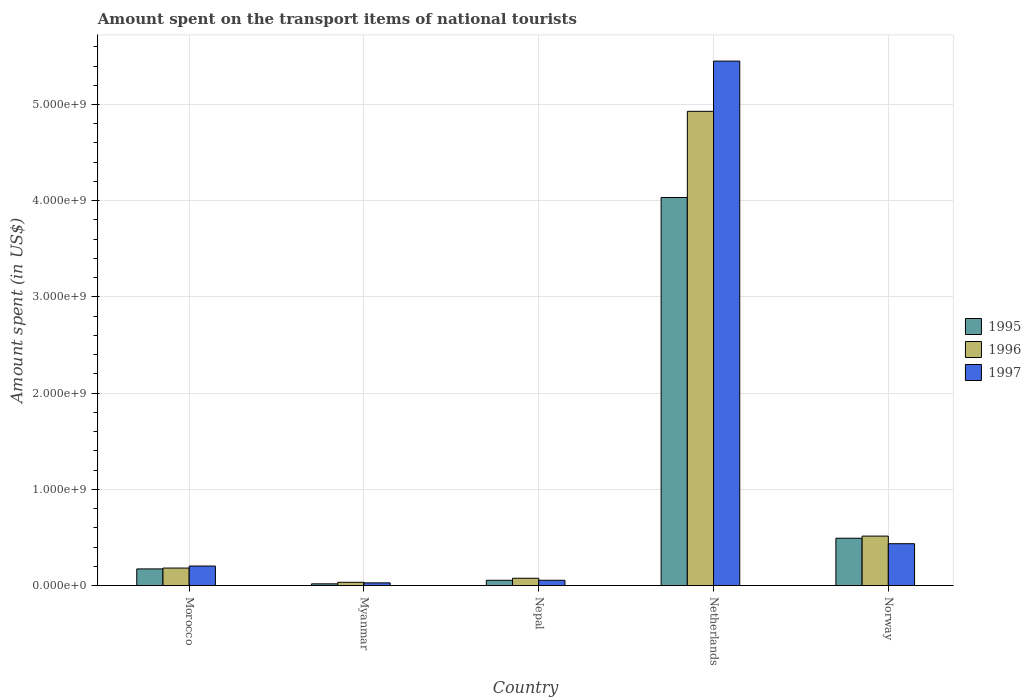How many different coloured bars are there?
Offer a very short reply. 3. Are the number of bars per tick equal to the number of legend labels?
Give a very brief answer. Yes. How many bars are there on the 5th tick from the left?
Offer a very short reply. 3. What is the label of the 2nd group of bars from the left?
Provide a short and direct response. Myanmar. In how many cases, is the number of bars for a given country not equal to the number of legend labels?
Provide a short and direct response. 0. What is the amount spent on the transport items of national tourists in 1997 in Nepal?
Ensure brevity in your answer.  5.50e+07. Across all countries, what is the maximum amount spent on the transport items of national tourists in 1997?
Offer a very short reply. 5.45e+09. Across all countries, what is the minimum amount spent on the transport items of national tourists in 1997?
Your answer should be very brief. 2.80e+07. In which country was the amount spent on the transport items of national tourists in 1997 minimum?
Ensure brevity in your answer.  Myanmar. What is the total amount spent on the transport items of national tourists in 1995 in the graph?
Your response must be concise. 4.77e+09. What is the difference between the amount spent on the transport items of national tourists in 1996 in Morocco and that in Netherlands?
Ensure brevity in your answer.  -4.75e+09. What is the difference between the amount spent on the transport items of national tourists in 1996 in Netherlands and the amount spent on the transport items of national tourists in 1997 in Nepal?
Ensure brevity in your answer.  4.87e+09. What is the average amount spent on the transport items of national tourists in 1996 per country?
Your answer should be compact. 1.15e+09. What is the difference between the amount spent on the transport items of national tourists of/in 1997 and amount spent on the transport items of national tourists of/in 1996 in Netherlands?
Your response must be concise. 5.22e+08. What is the ratio of the amount spent on the transport items of national tourists in 1996 in Morocco to that in Myanmar?
Keep it short and to the point. 5.35. What is the difference between the highest and the second highest amount spent on the transport items of national tourists in 1997?
Offer a very short reply. 5.25e+09. What is the difference between the highest and the lowest amount spent on the transport items of national tourists in 1996?
Provide a short and direct response. 4.90e+09. In how many countries, is the amount spent on the transport items of national tourists in 1997 greater than the average amount spent on the transport items of national tourists in 1997 taken over all countries?
Provide a short and direct response. 1. Is the sum of the amount spent on the transport items of national tourists in 1996 in Myanmar and Netherlands greater than the maximum amount spent on the transport items of national tourists in 1997 across all countries?
Your answer should be compact. No. What does the 2nd bar from the right in Morocco represents?
Provide a short and direct response. 1996. Is it the case that in every country, the sum of the amount spent on the transport items of national tourists in 1997 and amount spent on the transport items of national tourists in 1995 is greater than the amount spent on the transport items of national tourists in 1996?
Make the answer very short. Yes. How many bars are there?
Keep it short and to the point. 15. Are the values on the major ticks of Y-axis written in scientific E-notation?
Provide a succinct answer. Yes. How many legend labels are there?
Provide a short and direct response. 3. What is the title of the graph?
Provide a succinct answer. Amount spent on the transport items of national tourists. Does "2003" appear as one of the legend labels in the graph?
Your answer should be very brief. No. What is the label or title of the X-axis?
Your answer should be very brief. Country. What is the label or title of the Y-axis?
Ensure brevity in your answer.  Amount spent (in US$). What is the Amount spent (in US$) in 1995 in Morocco?
Offer a very short reply. 1.73e+08. What is the Amount spent (in US$) in 1996 in Morocco?
Your response must be concise. 1.82e+08. What is the Amount spent (in US$) of 1997 in Morocco?
Give a very brief answer. 2.03e+08. What is the Amount spent (in US$) in 1995 in Myanmar?
Offer a very short reply. 1.80e+07. What is the Amount spent (in US$) in 1996 in Myanmar?
Keep it short and to the point. 3.40e+07. What is the Amount spent (in US$) of 1997 in Myanmar?
Give a very brief answer. 2.80e+07. What is the Amount spent (in US$) in 1995 in Nepal?
Ensure brevity in your answer.  5.50e+07. What is the Amount spent (in US$) in 1996 in Nepal?
Ensure brevity in your answer.  7.60e+07. What is the Amount spent (in US$) in 1997 in Nepal?
Your answer should be compact. 5.50e+07. What is the Amount spent (in US$) in 1995 in Netherlands?
Provide a succinct answer. 4.03e+09. What is the Amount spent (in US$) in 1996 in Netherlands?
Provide a short and direct response. 4.93e+09. What is the Amount spent (in US$) of 1997 in Netherlands?
Provide a succinct answer. 5.45e+09. What is the Amount spent (in US$) in 1995 in Norway?
Give a very brief answer. 4.92e+08. What is the Amount spent (in US$) of 1996 in Norway?
Offer a very short reply. 5.14e+08. What is the Amount spent (in US$) in 1997 in Norway?
Ensure brevity in your answer.  4.35e+08. Across all countries, what is the maximum Amount spent (in US$) of 1995?
Your answer should be compact. 4.03e+09. Across all countries, what is the maximum Amount spent (in US$) of 1996?
Make the answer very short. 4.93e+09. Across all countries, what is the maximum Amount spent (in US$) of 1997?
Your answer should be very brief. 5.45e+09. Across all countries, what is the minimum Amount spent (in US$) in 1995?
Provide a succinct answer. 1.80e+07. Across all countries, what is the minimum Amount spent (in US$) in 1996?
Offer a very short reply. 3.40e+07. Across all countries, what is the minimum Amount spent (in US$) in 1997?
Keep it short and to the point. 2.80e+07. What is the total Amount spent (in US$) in 1995 in the graph?
Provide a short and direct response. 4.77e+09. What is the total Amount spent (in US$) in 1996 in the graph?
Offer a very short reply. 5.74e+09. What is the total Amount spent (in US$) of 1997 in the graph?
Make the answer very short. 6.17e+09. What is the difference between the Amount spent (in US$) in 1995 in Morocco and that in Myanmar?
Provide a short and direct response. 1.55e+08. What is the difference between the Amount spent (in US$) of 1996 in Morocco and that in Myanmar?
Give a very brief answer. 1.48e+08. What is the difference between the Amount spent (in US$) in 1997 in Morocco and that in Myanmar?
Give a very brief answer. 1.75e+08. What is the difference between the Amount spent (in US$) in 1995 in Morocco and that in Nepal?
Offer a terse response. 1.18e+08. What is the difference between the Amount spent (in US$) in 1996 in Morocco and that in Nepal?
Provide a succinct answer. 1.06e+08. What is the difference between the Amount spent (in US$) of 1997 in Morocco and that in Nepal?
Your answer should be compact. 1.48e+08. What is the difference between the Amount spent (in US$) of 1995 in Morocco and that in Netherlands?
Keep it short and to the point. -3.86e+09. What is the difference between the Amount spent (in US$) of 1996 in Morocco and that in Netherlands?
Make the answer very short. -4.75e+09. What is the difference between the Amount spent (in US$) of 1997 in Morocco and that in Netherlands?
Make the answer very short. -5.25e+09. What is the difference between the Amount spent (in US$) in 1995 in Morocco and that in Norway?
Keep it short and to the point. -3.19e+08. What is the difference between the Amount spent (in US$) in 1996 in Morocco and that in Norway?
Offer a very short reply. -3.32e+08. What is the difference between the Amount spent (in US$) of 1997 in Morocco and that in Norway?
Offer a very short reply. -2.32e+08. What is the difference between the Amount spent (in US$) in 1995 in Myanmar and that in Nepal?
Make the answer very short. -3.70e+07. What is the difference between the Amount spent (in US$) of 1996 in Myanmar and that in Nepal?
Provide a short and direct response. -4.20e+07. What is the difference between the Amount spent (in US$) of 1997 in Myanmar and that in Nepal?
Make the answer very short. -2.70e+07. What is the difference between the Amount spent (in US$) in 1995 in Myanmar and that in Netherlands?
Give a very brief answer. -4.02e+09. What is the difference between the Amount spent (in US$) in 1996 in Myanmar and that in Netherlands?
Make the answer very short. -4.90e+09. What is the difference between the Amount spent (in US$) in 1997 in Myanmar and that in Netherlands?
Your response must be concise. -5.42e+09. What is the difference between the Amount spent (in US$) of 1995 in Myanmar and that in Norway?
Your response must be concise. -4.74e+08. What is the difference between the Amount spent (in US$) in 1996 in Myanmar and that in Norway?
Your response must be concise. -4.80e+08. What is the difference between the Amount spent (in US$) in 1997 in Myanmar and that in Norway?
Provide a succinct answer. -4.07e+08. What is the difference between the Amount spent (in US$) of 1995 in Nepal and that in Netherlands?
Offer a terse response. -3.98e+09. What is the difference between the Amount spent (in US$) of 1996 in Nepal and that in Netherlands?
Your answer should be very brief. -4.85e+09. What is the difference between the Amount spent (in US$) in 1997 in Nepal and that in Netherlands?
Provide a short and direct response. -5.40e+09. What is the difference between the Amount spent (in US$) of 1995 in Nepal and that in Norway?
Provide a short and direct response. -4.37e+08. What is the difference between the Amount spent (in US$) in 1996 in Nepal and that in Norway?
Your answer should be very brief. -4.38e+08. What is the difference between the Amount spent (in US$) of 1997 in Nepal and that in Norway?
Offer a very short reply. -3.80e+08. What is the difference between the Amount spent (in US$) of 1995 in Netherlands and that in Norway?
Give a very brief answer. 3.54e+09. What is the difference between the Amount spent (in US$) in 1996 in Netherlands and that in Norway?
Provide a succinct answer. 4.42e+09. What is the difference between the Amount spent (in US$) of 1997 in Netherlands and that in Norway?
Your answer should be very brief. 5.02e+09. What is the difference between the Amount spent (in US$) in 1995 in Morocco and the Amount spent (in US$) in 1996 in Myanmar?
Make the answer very short. 1.39e+08. What is the difference between the Amount spent (in US$) in 1995 in Morocco and the Amount spent (in US$) in 1997 in Myanmar?
Your response must be concise. 1.45e+08. What is the difference between the Amount spent (in US$) of 1996 in Morocco and the Amount spent (in US$) of 1997 in Myanmar?
Keep it short and to the point. 1.54e+08. What is the difference between the Amount spent (in US$) in 1995 in Morocco and the Amount spent (in US$) in 1996 in Nepal?
Keep it short and to the point. 9.70e+07. What is the difference between the Amount spent (in US$) of 1995 in Morocco and the Amount spent (in US$) of 1997 in Nepal?
Give a very brief answer. 1.18e+08. What is the difference between the Amount spent (in US$) of 1996 in Morocco and the Amount spent (in US$) of 1997 in Nepal?
Your response must be concise. 1.27e+08. What is the difference between the Amount spent (in US$) of 1995 in Morocco and the Amount spent (in US$) of 1996 in Netherlands?
Offer a terse response. -4.76e+09. What is the difference between the Amount spent (in US$) of 1995 in Morocco and the Amount spent (in US$) of 1997 in Netherlands?
Offer a very short reply. -5.28e+09. What is the difference between the Amount spent (in US$) of 1996 in Morocco and the Amount spent (in US$) of 1997 in Netherlands?
Give a very brief answer. -5.27e+09. What is the difference between the Amount spent (in US$) in 1995 in Morocco and the Amount spent (in US$) in 1996 in Norway?
Provide a succinct answer. -3.41e+08. What is the difference between the Amount spent (in US$) in 1995 in Morocco and the Amount spent (in US$) in 1997 in Norway?
Your answer should be compact. -2.62e+08. What is the difference between the Amount spent (in US$) of 1996 in Morocco and the Amount spent (in US$) of 1997 in Norway?
Offer a very short reply. -2.53e+08. What is the difference between the Amount spent (in US$) of 1995 in Myanmar and the Amount spent (in US$) of 1996 in Nepal?
Give a very brief answer. -5.80e+07. What is the difference between the Amount spent (in US$) in 1995 in Myanmar and the Amount spent (in US$) in 1997 in Nepal?
Provide a short and direct response. -3.70e+07. What is the difference between the Amount spent (in US$) in 1996 in Myanmar and the Amount spent (in US$) in 1997 in Nepal?
Your answer should be compact. -2.10e+07. What is the difference between the Amount spent (in US$) in 1995 in Myanmar and the Amount spent (in US$) in 1996 in Netherlands?
Give a very brief answer. -4.91e+09. What is the difference between the Amount spent (in US$) of 1995 in Myanmar and the Amount spent (in US$) of 1997 in Netherlands?
Give a very brief answer. -5.43e+09. What is the difference between the Amount spent (in US$) of 1996 in Myanmar and the Amount spent (in US$) of 1997 in Netherlands?
Your answer should be compact. -5.42e+09. What is the difference between the Amount spent (in US$) in 1995 in Myanmar and the Amount spent (in US$) in 1996 in Norway?
Keep it short and to the point. -4.96e+08. What is the difference between the Amount spent (in US$) of 1995 in Myanmar and the Amount spent (in US$) of 1997 in Norway?
Give a very brief answer. -4.17e+08. What is the difference between the Amount spent (in US$) in 1996 in Myanmar and the Amount spent (in US$) in 1997 in Norway?
Give a very brief answer. -4.01e+08. What is the difference between the Amount spent (in US$) in 1995 in Nepal and the Amount spent (in US$) in 1996 in Netherlands?
Make the answer very short. -4.87e+09. What is the difference between the Amount spent (in US$) in 1995 in Nepal and the Amount spent (in US$) in 1997 in Netherlands?
Keep it short and to the point. -5.40e+09. What is the difference between the Amount spent (in US$) of 1996 in Nepal and the Amount spent (in US$) of 1997 in Netherlands?
Keep it short and to the point. -5.38e+09. What is the difference between the Amount spent (in US$) in 1995 in Nepal and the Amount spent (in US$) in 1996 in Norway?
Your answer should be very brief. -4.59e+08. What is the difference between the Amount spent (in US$) of 1995 in Nepal and the Amount spent (in US$) of 1997 in Norway?
Keep it short and to the point. -3.80e+08. What is the difference between the Amount spent (in US$) of 1996 in Nepal and the Amount spent (in US$) of 1997 in Norway?
Make the answer very short. -3.59e+08. What is the difference between the Amount spent (in US$) in 1995 in Netherlands and the Amount spent (in US$) in 1996 in Norway?
Keep it short and to the point. 3.52e+09. What is the difference between the Amount spent (in US$) of 1995 in Netherlands and the Amount spent (in US$) of 1997 in Norway?
Your response must be concise. 3.60e+09. What is the difference between the Amount spent (in US$) of 1996 in Netherlands and the Amount spent (in US$) of 1997 in Norway?
Provide a succinct answer. 4.49e+09. What is the average Amount spent (in US$) in 1995 per country?
Provide a succinct answer. 9.54e+08. What is the average Amount spent (in US$) of 1996 per country?
Ensure brevity in your answer.  1.15e+09. What is the average Amount spent (in US$) of 1997 per country?
Your answer should be very brief. 1.23e+09. What is the difference between the Amount spent (in US$) in 1995 and Amount spent (in US$) in 1996 in Morocco?
Give a very brief answer. -9.00e+06. What is the difference between the Amount spent (in US$) of 1995 and Amount spent (in US$) of 1997 in Morocco?
Ensure brevity in your answer.  -3.00e+07. What is the difference between the Amount spent (in US$) in 1996 and Amount spent (in US$) in 1997 in Morocco?
Provide a short and direct response. -2.10e+07. What is the difference between the Amount spent (in US$) of 1995 and Amount spent (in US$) of 1996 in Myanmar?
Your answer should be compact. -1.60e+07. What is the difference between the Amount spent (in US$) in 1995 and Amount spent (in US$) in 1997 in Myanmar?
Give a very brief answer. -1.00e+07. What is the difference between the Amount spent (in US$) in 1995 and Amount spent (in US$) in 1996 in Nepal?
Your answer should be very brief. -2.10e+07. What is the difference between the Amount spent (in US$) in 1996 and Amount spent (in US$) in 1997 in Nepal?
Offer a terse response. 2.10e+07. What is the difference between the Amount spent (in US$) in 1995 and Amount spent (in US$) in 1996 in Netherlands?
Keep it short and to the point. -8.96e+08. What is the difference between the Amount spent (in US$) in 1995 and Amount spent (in US$) in 1997 in Netherlands?
Give a very brief answer. -1.42e+09. What is the difference between the Amount spent (in US$) of 1996 and Amount spent (in US$) of 1997 in Netherlands?
Your answer should be compact. -5.22e+08. What is the difference between the Amount spent (in US$) of 1995 and Amount spent (in US$) of 1996 in Norway?
Your response must be concise. -2.20e+07. What is the difference between the Amount spent (in US$) of 1995 and Amount spent (in US$) of 1997 in Norway?
Offer a very short reply. 5.70e+07. What is the difference between the Amount spent (in US$) in 1996 and Amount spent (in US$) in 1997 in Norway?
Make the answer very short. 7.90e+07. What is the ratio of the Amount spent (in US$) of 1995 in Morocco to that in Myanmar?
Keep it short and to the point. 9.61. What is the ratio of the Amount spent (in US$) in 1996 in Morocco to that in Myanmar?
Offer a terse response. 5.35. What is the ratio of the Amount spent (in US$) of 1997 in Morocco to that in Myanmar?
Give a very brief answer. 7.25. What is the ratio of the Amount spent (in US$) in 1995 in Morocco to that in Nepal?
Give a very brief answer. 3.15. What is the ratio of the Amount spent (in US$) of 1996 in Morocco to that in Nepal?
Provide a short and direct response. 2.39. What is the ratio of the Amount spent (in US$) of 1997 in Morocco to that in Nepal?
Give a very brief answer. 3.69. What is the ratio of the Amount spent (in US$) in 1995 in Morocco to that in Netherlands?
Provide a succinct answer. 0.04. What is the ratio of the Amount spent (in US$) in 1996 in Morocco to that in Netherlands?
Provide a short and direct response. 0.04. What is the ratio of the Amount spent (in US$) in 1997 in Morocco to that in Netherlands?
Offer a terse response. 0.04. What is the ratio of the Amount spent (in US$) in 1995 in Morocco to that in Norway?
Give a very brief answer. 0.35. What is the ratio of the Amount spent (in US$) of 1996 in Morocco to that in Norway?
Offer a very short reply. 0.35. What is the ratio of the Amount spent (in US$) of 1997 in Morocco to that in Norway?
Offer a very short reply. 0.47. What is the ratio of the Amount spent (in US$) of 1995 in Myanmar to that in Nepal?
Ensure brevity in your answer.  0.33. What is the ratio of the Amount spent (in US$) in 1996 in Myanmar to that in Nepal?
Keep it short and to the point. 0.45. What is the ratio of the Amount spent (in US$) in 1997 in Myanmar to that in Nepal?
Make the answer very short. 0.51. What is the ratio of the Amount spent (in US$) in 1995 in Myanmar to that in Netherlands?
Ensure brevity in your answer.  0. What is the ratio of the Amount spent (in US$) in 1996 in Myanmar to that in Netherlands?
Provide a succinct answer. 0.01. What is the ratio of the Amount spent (in US$) in 1997 in Myanmar to that in Netherlands?
Offer a very short reply. 0.01. What is the ratio of the Amount spent (in US$) in 1995 in Myanmar to that in Norway?
Offer a terse response. 0.04. What is the ratio of the Amount spent (in US$) in 1996 in Myanmar to that in Norway?
Your response must be concise. 0.07. What is the ratio of the Amount spent (in US$) in 1997 in Myanmar to that in Norway?
Your answer should be very brief. 0.06. What is the ratio of the Amount spent (in US$) of 1995 in Nepal to that in Netherlands?
Give a very brief answer. 0.01. What is the ratio of the Amount spent (in US$) of 1996 in Nepal to that in Netherlands?
Give a very brief answer. 0.02. What is the ratio of the Amount spent (in US$) in 1997 in Nepal to that in Netherlands?
Give a very brief answer. 0.01. What is the ratio of the Amount spent (in US$) of 1995 in Nepal to that in Norway?
Make the answer very short. 0.11. What is the ratio of the Amount spent (in US$) of 1996 in Nepal to that in Norway?
Ensure brevity in your answer.  0.15. What is the ratio of the Amount spent (in US$) of 1997 in Nepal to that in Norway?
Ensure brevity in your answer.  0.13. What is the ratio of the Amount spent (in US$) of 1995 in Netherlands to that in Norway?
Provide a short and direct response. 8.2. What is the ratio of the Amount spent (in US$) in 1996 in Netherlands to that in Norway?
Keep it short and to the point. 9.59. What is the ratio of the Amount spent (in US$) of 1997 in Netherlands to that in Norway?
Offer a very short reply. 12.53. What is the difference between the highest and the second highest Amount spent (in US$) in 1995?
Provide a short and direct response. 3.54e+09. What is the difference between the highest and the second highest Amount spent (in US$) in 1996?
Give a very brief answer. 4.42e+09. What is the difference between the highest and the second highest Amount spent (in US$) of 1997?
Give a very brief answer. 5.02e+09. What is the difference between the highest and the lowest Amount spent (in US$) in 1995?
Your answer should be compact. 4.02e+09. What is the difference between the highest and the lowest Amount spent (in US$) in 1996?
Provide a succinct answer. 4.90e+09. What is the difference between the highest and the lowest Amount spent (in US$) in 1997?
Give a very brief answer. 5.42e+09. 